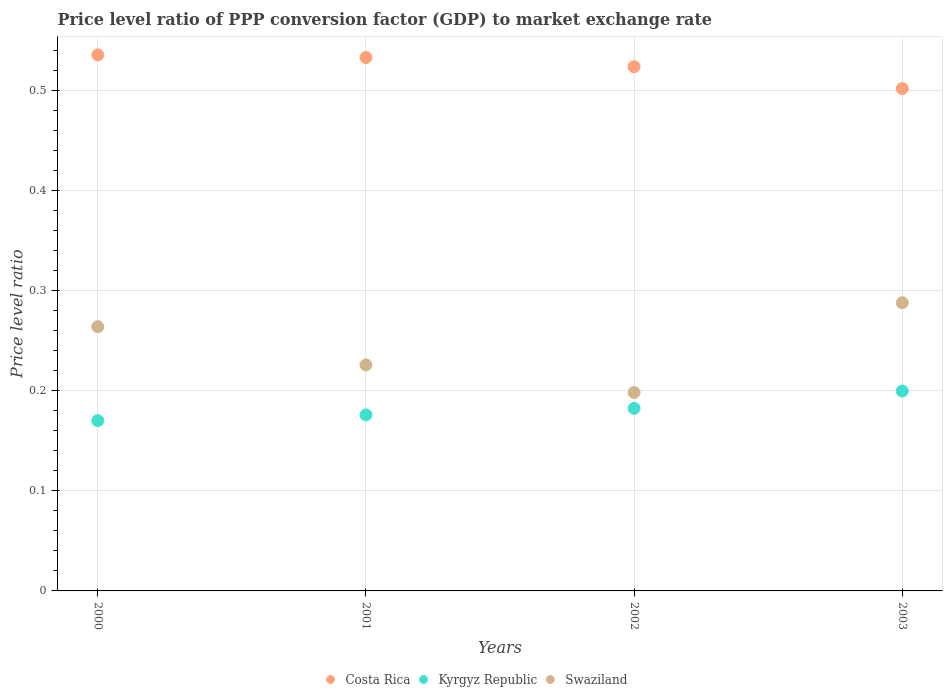Is the number of dotlines equal to the number of legend labels?
Keep it short and to the point. Yes. What is the price level ratio in Swaziland in 2002?
Your answer should be very brief. 0.2. Across all years, what is the maximum price level ratio in Costa Rica?
Provide a succinct answer. 0.54. Across all years, what is the minimum price level ratio in Kyrgyz Republic?
Your answer should be very brief. 0.17. In which year was the price level ratio in Swaziland maximum?
Keep it short and to the point. 2003. In which year was the price level ratio in Costa Rica minimum?
Keep it short and to the point. 2003. What is the total price level ratio in Kyrgyz Republic in the graph?
Your answer should be very brief. 0.73. What is the difference between the price level ratio in Costa Rica in 2001 and that in 2002?
Your answer should be compact. 0.01. What is the difference between the price level ratio in Kyrgyz Republic in 2003 and the price level ratio in Swaziland in 2001?
Your answer should be compact. -0.03. What is the average price level ratio in Costa Rica per year?
Keep it short and to the point. 0.52. In the year 2002, what is the difference between the price level ratio in Kyrgyz Republic and price level ratio in Costa Rica?
Ensure brevity in your answer.  -0.34. In how many years, is the price level ratio in Kyrgyz Republic greater than 0.04?
Offer a terse response. 4. What is the ratio of the price level ratio in Kyrgyz Republic in 2000 to that in 2002?
Your answer should be very brief. 0.93. Is the price level ratio in Swaziland in 2000 less than that in 2001?
Ensure brevity in your answer.  No. What is the difference between the highest and the second highest price level ratio in Kyrgyz Republic?
Keep it short and to the point. 0.02. What is the difference between the highest and the lowest price level ratio in Swaziland?
Offer a terse response. 0.09. In how many years, is the price level ratio in Costa Rica greater than the average price level ratio in Costa Rica taken over all years?
Provide a short and direct response. 3. Does the price level ratio in Swaziland monotonically increase over the years?
Make the answer very short. No. Is the price level ratio in Swaziland strictly less than the price level ratio in Costa Rica over the years?
Offer a very short reply. Yes. How many years are there in the graph?
Provide a short and direct response. 4. Are the values on the major ticks of Y-axis written in scientific E-notation?
Offer a terse response. No. Does the graph contain any zero values?
Keep it short and to the point. No. Where does the legend appear in the graph?
Keep it short and to the point. Bottom center. What is the title of the graph?
Ensure brevity in your answer.  Price level ratio of PPP conversion factor (GDP) to market exchange rate. What is the label or title of the X-axis?
Give a very brief answer. Years. What is the label or title of the Y-axis?
Keep it short and to the point. Price level ratio. What is the Price level ratio of Costa Rica in 2000?
Offer a terse response. 0.54. What is the Price level ratio of Kyrgyz Republic in 2000?
Your answer should be very brief. 0.17. What is the Price level ratio of Swaziland in 2000?
Keep it short and to the point. 0.26. What is the Price level ratio in Costa Rica in 2001?
Provide a succinct answer. 0.53. What is the Price level ratio in Kyrgyz Republic in 2001?
Your response must be concise. 0.18. What is the Price level ratio in Swaziland in 2001?
Your answer should be very brief. 0.23. What is the Price level ratio in Costa Rica in 2002?
Offer a terse response. 0.52. What is the Price level ratio in Kyrgyz Republic in 2002?
Make the answer very short. 0.18. What is the Price level ratio in Swaziland in 2002?
Your answer should be very brief. 0.2. What is the Price level ratio of Costa Rica in 2003?
Offer a very short reply. 0.5. What is the Price level ratio of Kyrgyz Republic in 2003?
Offer a terse response. 0.2. What is the Price level ratio of Swaziland in 2003?
Provide a succinct answer. 0.29. Across all years, what is the maximum Price level ratio of Costa Rica?
Your answer should be very brief. 0.54. Across all years, what is the maximum Price level ratio of Kyrgyz Republic?
Offer a very short reply. 0.2. Across all years, what is the maximum Price level ratio of Swaziland?
Keep it short and to the point. 0.29. Across all years, what is the minimum Price level ratio in Costa Rica?
Your response must be concise. 0.5. Across all years, what is the minimum Price level ratio of Kyrgyz Republic?
Give a very brief answer. 0.17. Across all years, what is the minimum Price level ratio in Swaziland?
Offer a very short reply. 0.2. What is the total Price level ratio in Costa Rica in the graph?
Offer a terse response. 2.09. What is the total Price level ratio in Kyrgyz Republic in the graph?
Make the answer very short. 0.73. What is the total Price level ratio of Swaziland in the graph?
Your answer should be compact. 0.98. What is the difference between the Price level ratio of Costa Rica in 2000 and that in 2001?
Your answer should be compact. 0. What is the difference between the Price level ratio in Kyrgyz Republic in 2000 and that in 2001?
Provide a succinct answer. -0.01. What is the difference between the Price level ratio of Swaziland in 2000 and that in 2001?
Provide a short and direct response. 0.04. What is the difference between the Price level ratio in Costa Rica in 2000 and that in 2002?
Your answer should be very brief. 0.01. What is the difference between the Price level ratio in Kyrgyz Republic in 2000 and that in 2002?
Ensure brevity in your answer.  -0.01. What is the difference between the Price level ratio in Swaziland in 2000 and that in 2002?
Make the answer very short. 0.07. What is the difference between the Price level ratio in Costa Rica in 2000 and that in 2003?
Make the answer very short. 0.03. What is the difference between the Price level ratio of Kyrgyz Republic in 2000 and that in 2003?
Make the answer very short. -0.03. What is the difference between the Price level ratio in Swaziland in 2000 and that in 2003?
Offer a very short reply. -0.02. What is the difference between the Price level ratio of Costa Rica in 2001 and that in 2002?
Make the answer very short. 0.01. What is the difference between the Price level ratio of Kyrgyz Republic in 2001 and that in 2002?
Provide a short and direct response. -0.01. What is the difference between the Price level ratio of Swaziland in 2001 and that in 2002?
Your answer should be compact. 0.03. What is the difference between the Price level ratio in Costa Rica in 2001 and that in 2003?
Your answer should be compact. 0.03. What is the difference between the Price level ratio of Kyrgyz Republic in 2001 and that in 2003?
Offer a very short reply. -0.02. What is the difference between the Price level ratio in Swaziland in 2001 and that in 2003?
Offer a very short reply. -0.06. What is the difference between the Price level ratio in Costa Rica in 2002 and that in 2003?
Keep it short and to the point. 0.02. What is the difference between the Price level ratio in Kyrgyz Republic in 2002 and that in 2003?
Provide a short and direct response. -0.02. What is the difference between the Price level ratio in Swaziland in 2002 and that in 2003?
Offer a very short reply. -0.09. What is the difference between the Price level ratio in Costa Rica in 2000 and the Price level ratio in Kyrgyz Republic in 2001?
Make the answer very short. 0.36. What is the difference between the Price level ratio in Costa Rica in 2000 and the Price level ratio in Swaziland in 2001?
Keep it short and to the point. 0.31. What is the difference between the Price level ratio in Kyrgyz Republic in 2000 and the Price level ratio in Swaziland in 2001?
Ensure brevity in your answer.  -0.06. What is the difference between the Price level ratio of Costa Rica in 2000 and the Price level ratio of Kyrgyz Republic in 2002?
Your answer should be compact. 0.35. What is the difference between the Price level ratio in Costa Rica in 2000 and the Price level ratio in Swaziland in 2002?
Ensure brevity in your answer.  0.34. What is the difference between the Price level ratio of Kyrgyz Republic in 2000 and the Price level ratio of Swaziland in 2002?
Your answer should be very brief. -0.03. What is the difference between the Price level ratio of Costa Rica in 2000 and the Price level ratio of Kyrgyz Republic in 2003?
Make the answer very short. 0.34. What is the difference between the Price level ratio in Costa Rica in 2000 and the Price level ratio in Swaziland in 2003?
Keep it short and to the point. 0.25. What is the difference between the Price level ratio of Kyrgyz Republic in 2000 and the Price level ratio of Swaziland in 2003?
Make the answer very short. -0.12. What is the difference between the Price level ratio of Costa Rica in 2001 and the Price level ratio of Kyrgyz Republic in 2002?
Ensure brevity in your answer.  0.35. What is the difference between the Price level ratio of Costa Rica in 2001 and the Price level ratio of Swaziland in 2002?
Offer a terse response. 0.33. What is the difference between the Price level ratio in Kyrgyz Republic in 2001 and the Price level ratio in Swaziland in 2002?
Provide a short and direct response. -0.02. What is the difference between the Price level ratio of Costa Rica in 2001 and the Price level ratio of Kyrgyz Republic in 2003?
Ensure brevity in your answer.  0.33. What is the difference between the Price level ratio of Costa Rica in 2001 and the Price level ratio of Swaziland in 2003?
Provide a short and direct response. 0.24. What is the difference between the Price level ratio of Kyrgyz Republic in 2001 and the Price level ratio of Swaziland in 2003?
Offer a terse response. -0.11. What is the difference between the Price level ratio in Costa Rica in 2002 and the Price level ratio in Kyrgyz Republic in 2003?
Your answer should be compact. 0.32. What is the difference between the Price level ratio in Costa Rica in 2002 and the Price level ratio in Swaziland in 2003?
Your answer should be compact. 0.24. What is the difference between the Price level ratio in Kyrgyz Republic in 2002 and the Price level ratio in Swaziland in 2003?
Your answer should be very brief. -0.11. What is the average Price level ratio of Costa Rica per year?
Provide a succinct answer. 0.52. What is the average Price level ratio in Kyrgyz Republic per year?
Keep it short and to the point. 0.18. What is the average Price level ratio in Swaziland per year?
Keep it short and to the point. 0.24. In the year 2000, what is the difference between the Price level ratio of Costa Rica and Price level ratio of Kyrgyz Republic?
Make the answer very short. 0.37. In the year 2000, what is the difference between the Price level ratio in Costa Rica and Price level ratio in Swaziland?
Make the answer very short. 0.27. In the year 2000, what is the difference between the Price level ratio in Kyrgyz Republic and Price level ratio in Swaziland?
Ensure brevity in your answer.  -0.09. In the year 2001, what is the difference between the Price level ratio of Costa Rica and Price level ratio of Kyrgyz Republic?
Make the answer very short. 0.36. In the year 2001, what is the difference between the Price level ratio of Costa Rica and Price level ratio of Swaziland?
Make the answer very short. 0.31. In the year 2001, what is the difference between the Price level ratio of Kyrgyz Republic and Price level ratio of Swaziland?
Offer a very short reply. -0.05. In the year 2002, what is the difference between the Price level ratio in Costa Rica and Price level ratio in Kyrgyz Republic?
Ensure brevity in your answer.  0.34. In the year 2002, what is the difference between the Price level ratio in Costa Rica and Price level ratio in Swaziland?
Ensure brevity in your answer.  0.33. In the year 2002, what is the difference between the Price level ratio in Kyrgyz Republic and Price level ratio in Swaziland?
Provide a short and direct response. -0.02. In the year 2003, what is the difference between the Price level ratio in Costa Rica and Price level ratio in Kyrgyz Republic?
Offer a very short reply. 0.3. In the year 2003, what is the difference between the Price level ratio in Costa Rica and Price level ratio in Swaziland?
Ensure brevity in your answer.  0.21. In the year 2003, what is the difference between the Price level ratio of Kyrgyz Republic and Price level ratio of Swaziland?
Provide a succinct answer. -0.09. What is the ratio of the Price level ratio in Costa Rica in 2000 to that in 2001?
Provide a succinct answer. 1. What is the ratio of the Price level ratio of Kyrgyz Republic in 2000 to that in 2001?
Ensure brevity in your answer.  0.97. What is the ratio of the Price level ratio of Swaziland in 2000 to that in 2001?
Offer a very short reply. 1.17. What is the ratio of the Price level ratio of Costa Rica in 2000 to that in 2002?
Make the answer very short. 1.02. What is the ratio of the Price level ratio in Kyrgyz Republic in 2000 to that in 2002?
Provide a short and direct response. 0.93. What is the ratio of the Price level ratio in Swaziland in 2000 to that in 2002?
Provide a succinct answer. 1.33. What is the ratio of the Price level ratio in Costa Rica in 2000 to that in 2003?
Ensure brevity in your answer.  1.07. What is the ratio of the Price level ratio of Kyrgyz Republic in 2000 to that in 2003?
Offer a terse response. 0.85. What is the ratio of the Price level ratio of Swaziland in 2000 to that in 2003?
Make the answer very short. 0.92. What is the ratio of the Price level ratio in Costa Rica in 2001 to that in 2002?
Provide a short and direct response. 1.02. What is the ratio of the Price level ratio of Swaziland in 2001 to that in 2002?
Offer a terse response. 1.14. What is the ratio of the Price level ratio in Costa Rica in 2001 to that in 2003?
Your response must be concise. 1.06. What is the ratio of the Price level ratio in Kyrgyz Republic in 2001 to that in 2003?
Your answer should be compact. 0.88. What is the ratio of the Price level ratio of Swaziland in 2001 to that in 2003?
Provide a succinct answer. 0.78. What is the ratio of the Price level ratio in Costa Rica in 2002 to that in 2003?
Your response must be concise. 1.04. What is the ratio of the Price level ratio in Kyrgyz Republic in 2002 to that in 2003?
Give a very brief answer. 0.91. What is the ratio of the Price level ratio of Swaziland in 2002 to that in 2003?
Your answer should be very brief. 0.69. What is the difference between the highest and the second highest Price level ratio of Costa Rica?
Your answer should be very brief. 0. What is the difference between the highest and the second highest Price level ratio in Kyrgyz Republic?
Provide a succinct answer. 0.02. What is the difference between the highest and the second highest Price level ratio in Swaziland?
Offer a terse response. 0.02. What is the difference between the highest and the lowest Price level ratio in Costa Rica?
Your response must be concise. 0.03. What is the difference between the highest and the lowest Price level ratio of Kyrgyz Republic?
Ensure brevity in your answer.  0.03. What is the difference between the highest and the lowest Price level ratio in Swaziland?
Offer a terse response. 0.09. 